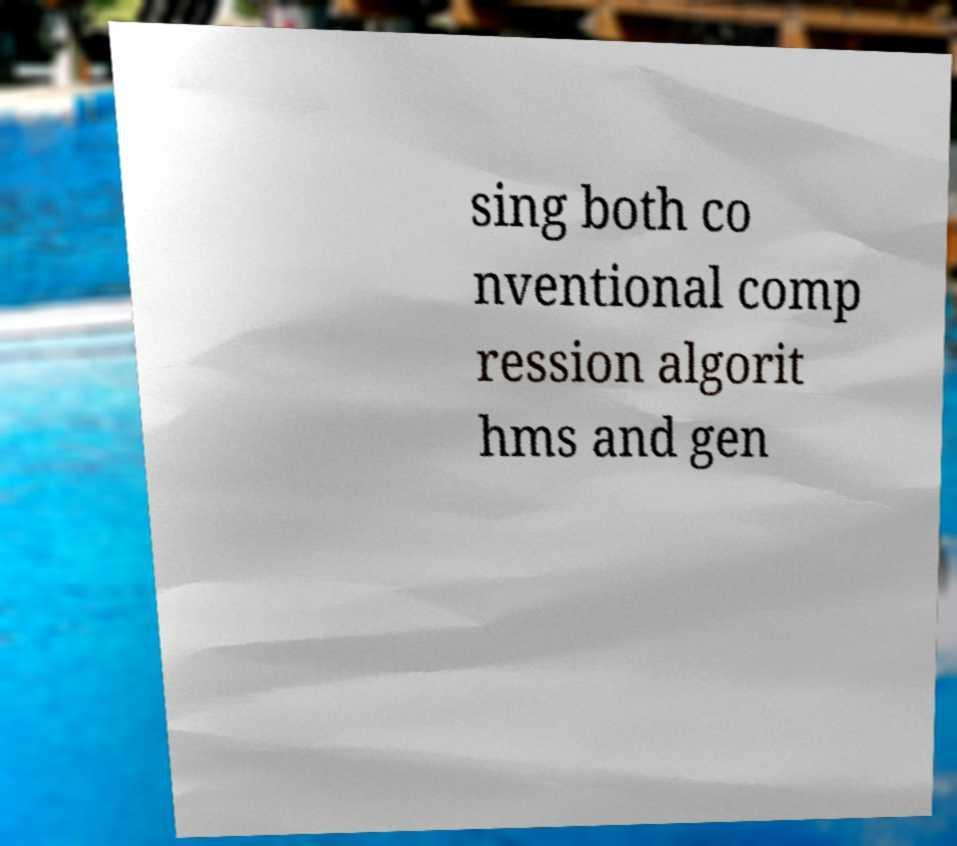Please identify and transcribe the text found in this image. sing both co nventional comp ression algorit hms and gen 